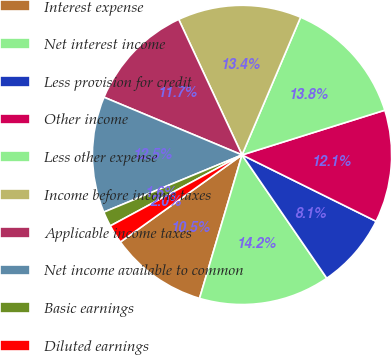<chart> <loc_0><loc_0><loc_500><loc_500><pie_chart><fcel>Interest expense<fcel>Net interest income<fcel>Less provision for credit<fcel>Other income<fcel>Less other expense<fcel>Income before income taxes<fcel>Applicable income taxes<fcel>Net income available to common<fcel>Basic earnings<fcel>Diluted earnings<nl><fcel>10.53%<fcel>14.17%<fcel>8.1%<fcel>12.15%<fcel>13.77%<fcel>13.36%<fcel>11.74%<fcel>12.55%<fcel>1.62%<fcel>2.02%<nl></chart> 